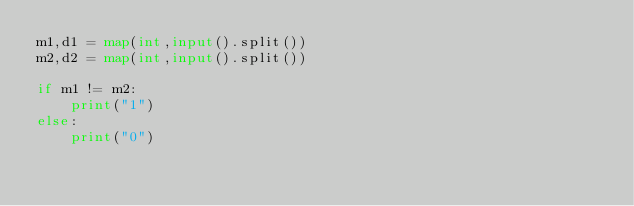Convert code to text. <code><loc_0><loc_0><loc_500><loc_500><_Python_>m1,d1 = map(int,input().split())
m2,d2 = map(int,input().split())

if m1 != m2:
    print("1")
else:
    print("0")
</code> 